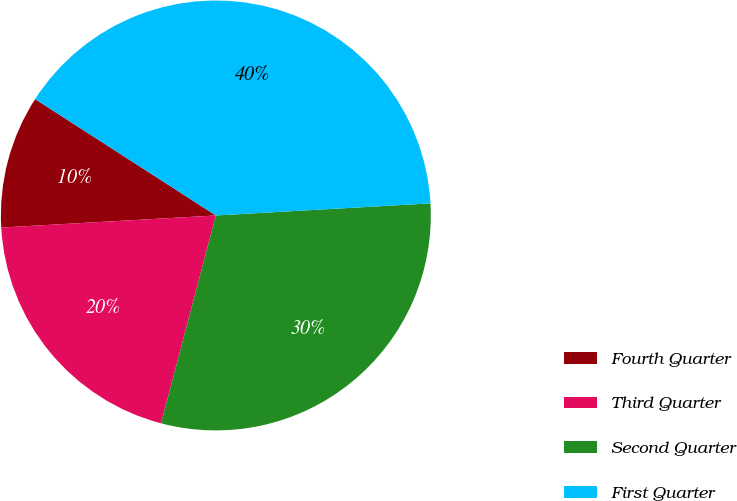Convert chart. <chart><loc_0><loc_0><loc_500><loc_500><pie_chart><fcel>Fourth Quarter<fcel>Third Quarter<fcel>Second Quarter<fcel>First Quarter<nl><fcel>10.0%<fcel>20.0%<fcel>30.0%<fcel>40.0%<nl></chart> 